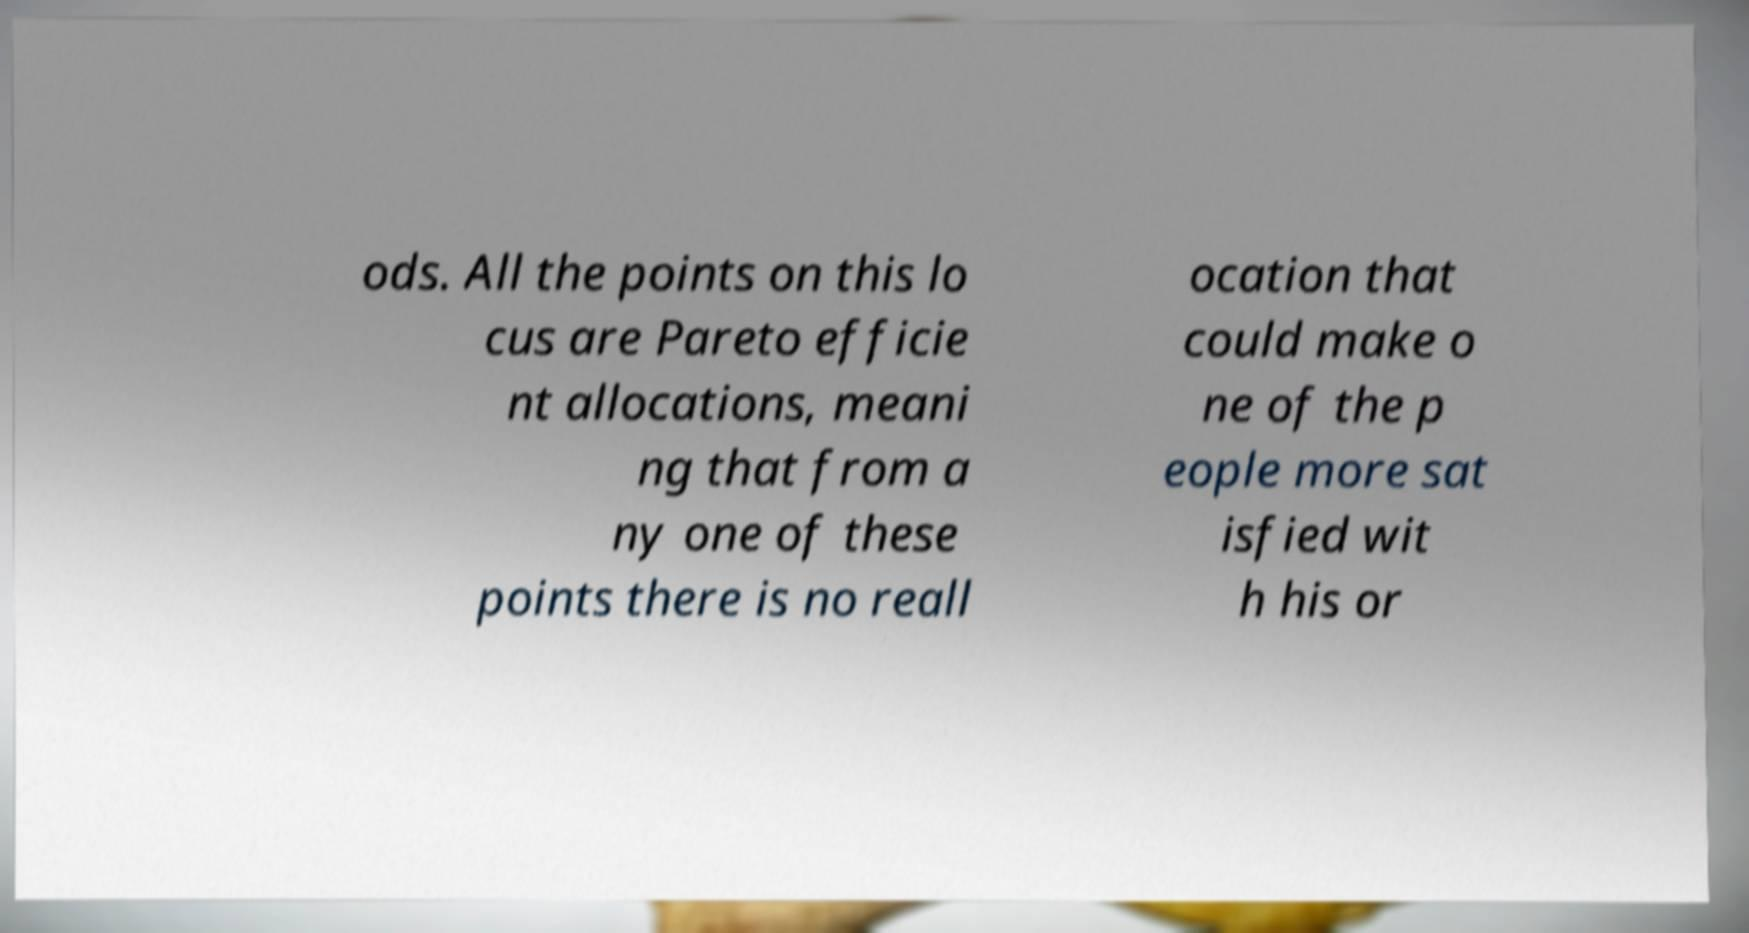There's text embedded in this image that I need extracted. Can you transcribe it verbatim? ods. All the points on this lo cus are Pareto efficie nt allocations, meani ng that from a ny one of these points there is no reall ocation that could make o ne of the p eople more sat isfied wit h his or 